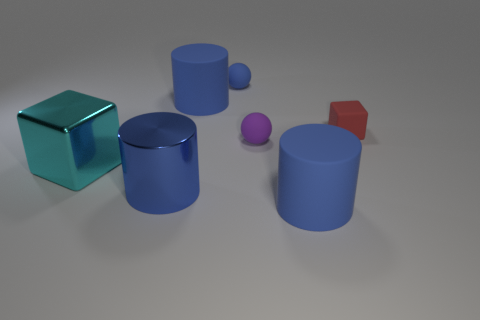Add 1 small yellow things. How many objects exist? 8 Subtract all cylinders. How many objects are left? 4 Subtract 0 brown cylinders. How many objects are left? 7 Subtract all green cubes. Subtract all tiny purple balls. How many objects are left? 6 Add 2 big blue cylinders. How many big blue cylinders are left? 5 Add 1 small purple rubber balls. How many small purple rubber balls exist? 2 